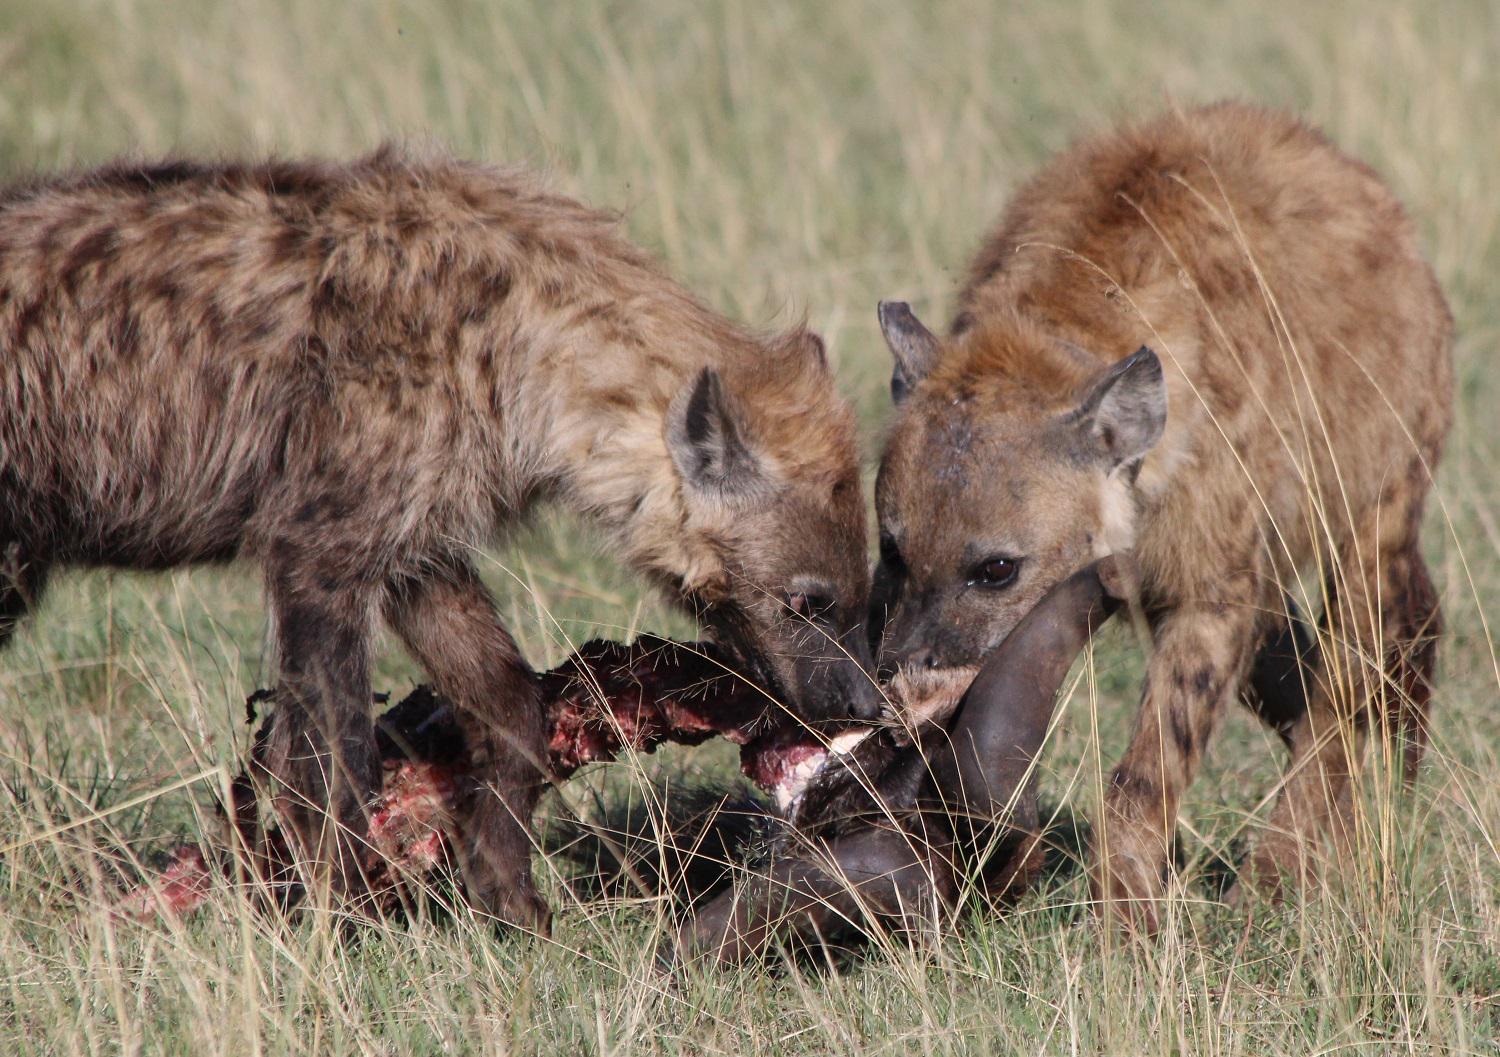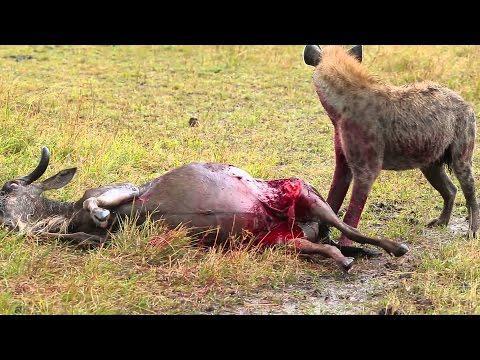The first image is the image on the left, the second image is the image on the right. For the images displayed, is the sentence "In the left image there are two hyenas feeding on a dead animal." factually correct? Answer yes or no. Yes. 